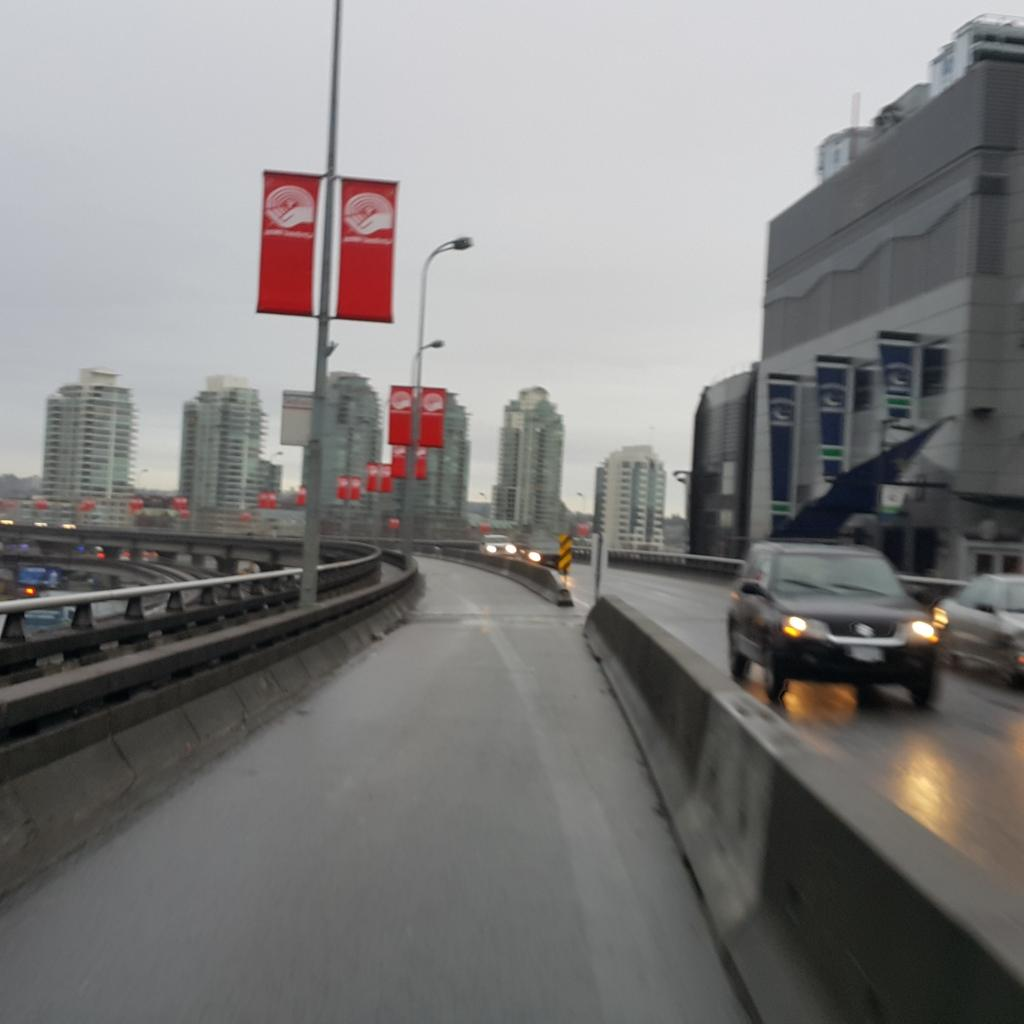What can be seen on the road in the image? There are vehicles on the road in the image. What is visible in the background of the image? There are buildings in the background of the image. Where are the poles located in the image? The poles are in the left corner of the image. Can you tell me how many plastic parcels are hanging from the poles in the image? There are no plastic parcels present in the image; only vehicles, buildings, and poles are visible. What type of boundary can be seen in the image? There is no boundary visible in the image; it features vehicles on the road, buildings in the background, and poles in the left corner. 